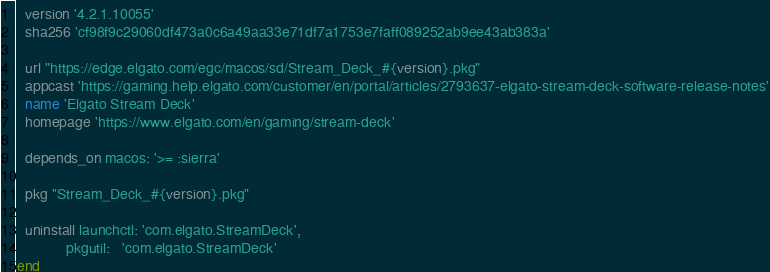<code> <loc_0><loc_0><loc_500><loc_500><_Ruby_>  version '4.2.1.10055'
  sha256 'cf98f9c29060df473a0c6a49aa33e71df7a1753e7faff089252ab9ee43ab383a'

  url "https://edge.elgato.com/egc/macos/sd/Stream_Deck_#{version}.pkg"
  appcast 'https://gaming.help.elgato.com/customer/en/portal/articles/2793637-elgato-stream-deck-software-release-notes'
  name 'Elgato Stream Deck'
  homepage 'https://www.elgato.com/en/gaming/stream-deck'

  depends_on macos: '>= :sierra'

  pkg "Stream_Deck_#{version}.pkg"

  uninstall launchctl: 'com.elgato.StreamDeck',
            pkgutil:   'com.elgato.StreamDeck'
end
</code> 